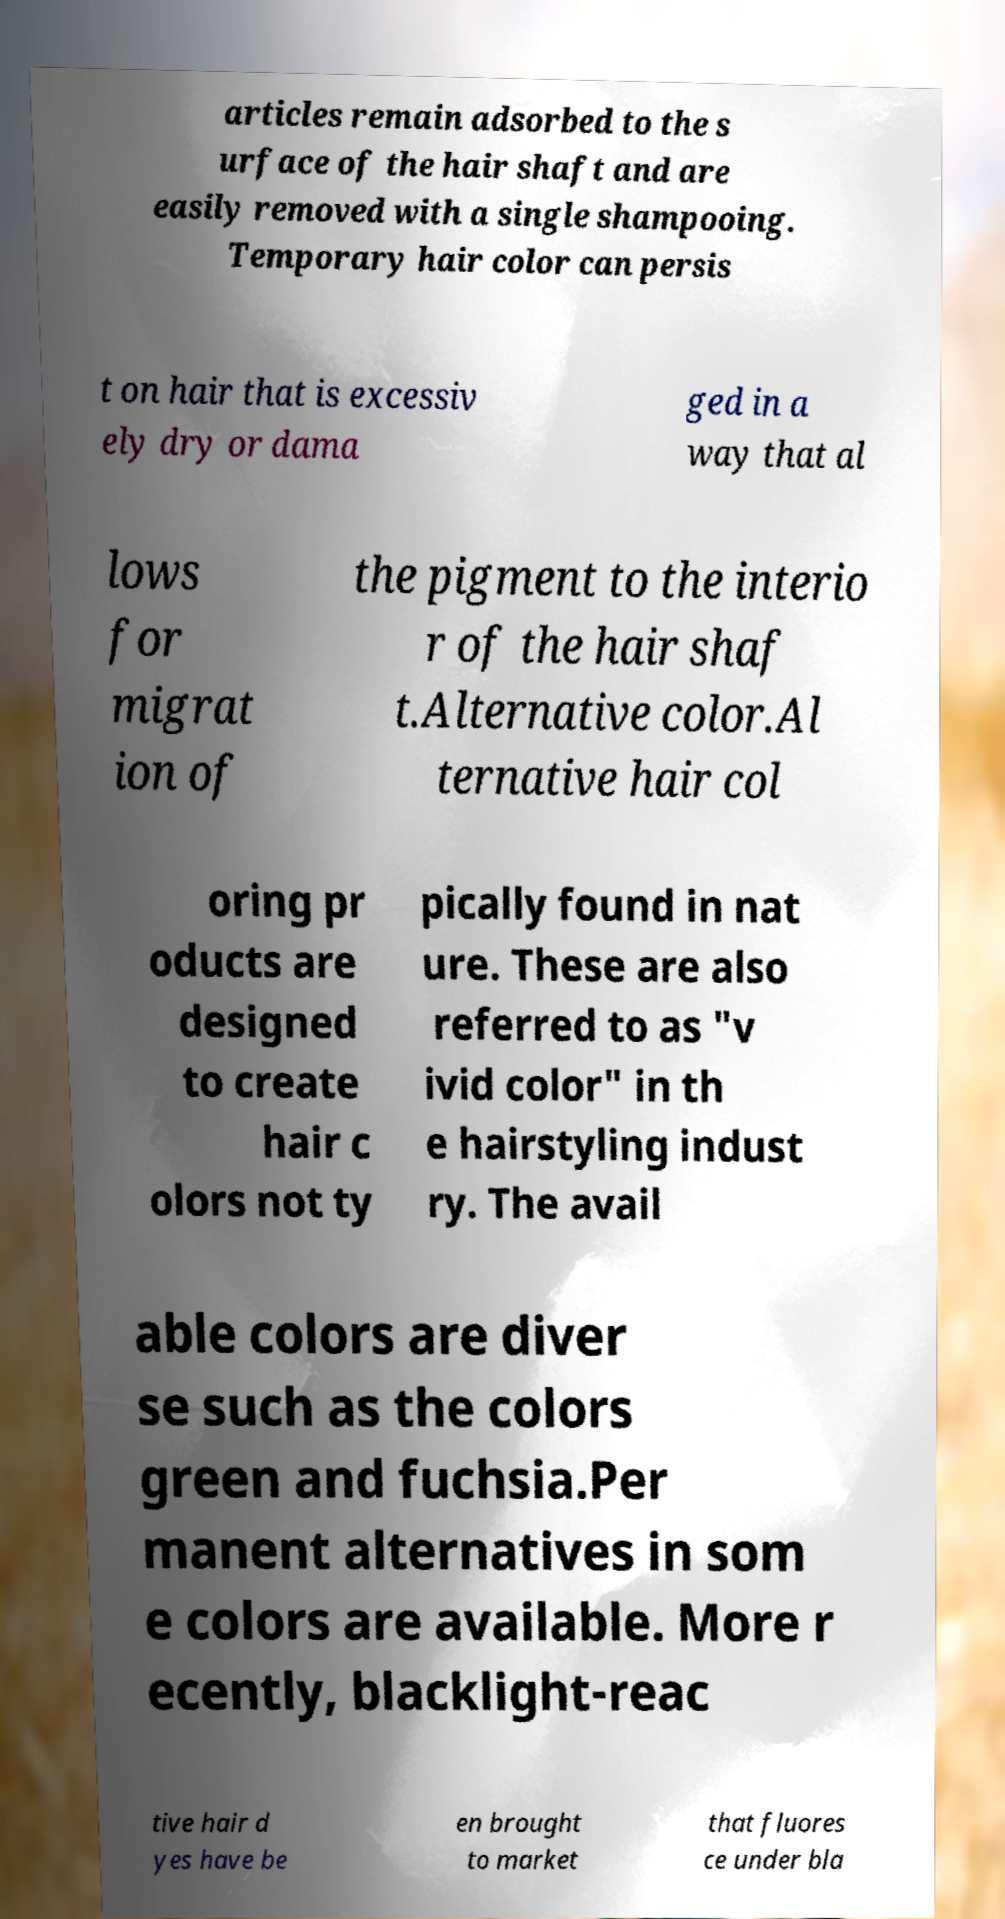Can you accurately transcribe the text from the provided image for me? articles remain adsorbed to the s urface of the hair shaft and are easily removed with a single shampooing. Temporary hair color can persis t on hair that is excessiv ely dry or dama ged in a way that al lows for migrat ion of the pigment to the interio r of the hair shaf t.Alternative color.Al ternative hair col oring pr oducts are designed to create hair c olors not ty pically found in nat ure. These are also referred to as "v ivid color" in th e hairstyling indust ry. The avail able colors are diver se such as the colors green and fuchsia.Per manent alternatives in som e colors are available. More r ecently, blacklight-reac tive hair d yes have be en brought to market that fluores ce under bla 